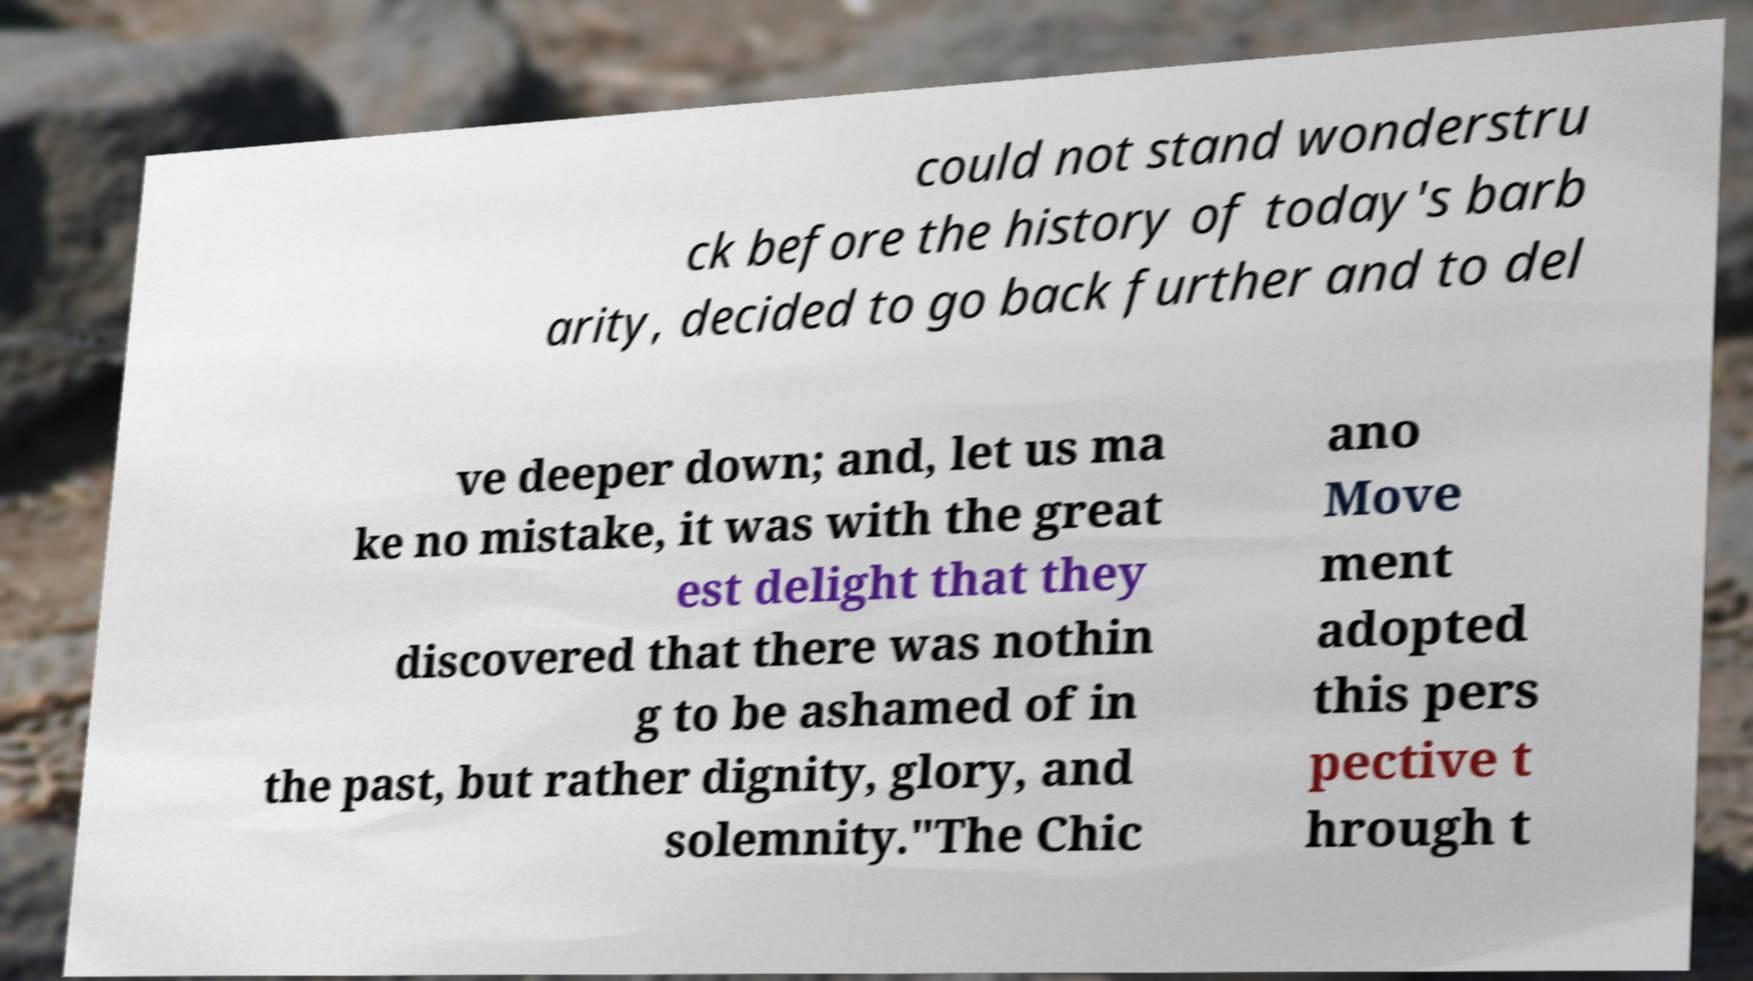Please read and relay the text visible in this image. What does it say? could not stand wonderstru ck before the history of today's barb arity, decided to go back further and to del ve deeper down; and, let us ma ke no mistake, it was with the great est delight that they discovered that there was nothin g to be ashamed of in the past, but rather dignity, glory, and solemnity."The Chic ano Move ment adopted this pers pective t hrough t 